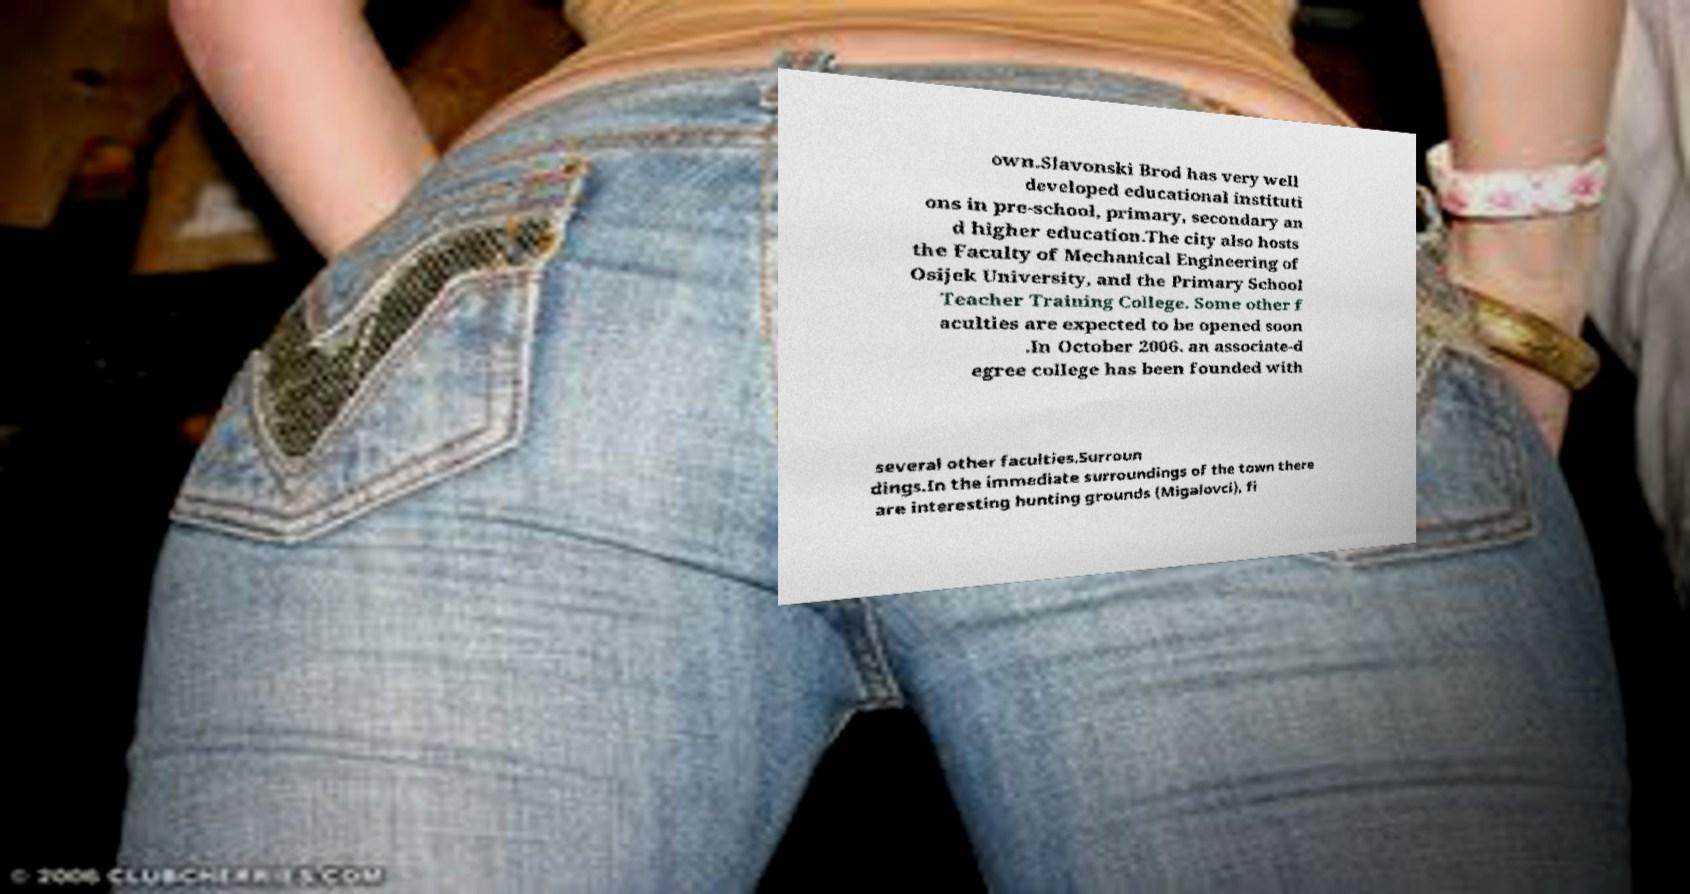For documentation purposes, I need the text within this image transcribed. Could you provide that? own.Slavonski Brod has very well developed educational instituti ons in pre-school, primary, secondary an d higher education.The city also hosts the Faculty of Mechanical Engineering of Osijek University, and the Primary School Teacher Training College. Some other f aculties are expected to be opened soon .In October 2006. an associate-d egree college has been founded with several other faculties.Surroun dings.In the immediate surroundings of the town there are interesting hunting grounds (Migalovci), fi 